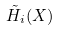Convert formula to latex. <formula><loc_0><loc_0><loc_500><loc_500>\tilde { H } _ { i } ( X )</formula> 